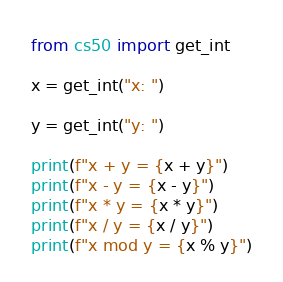<code> <loc_0><loc_0><loc_500><loc_500><_Python_>from cs50 import get_int

x = get_int("x: ")

y = get_int("y: ")

print(f"x + y = {x + y}")
print(f"x - y = {x - y}")
print(f"x * y = {x * y}")
print(f"x / y = {x / y}")
print(f"x mod y = {x % y}")
</code> 